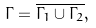Convert formula to latex. <formula><loc_0><loc_0><loc_500><loc_500>\Gamma = \overline { \Gamma _ { 1 } \cup \Gamma _ { 2 } } ,</formula> 